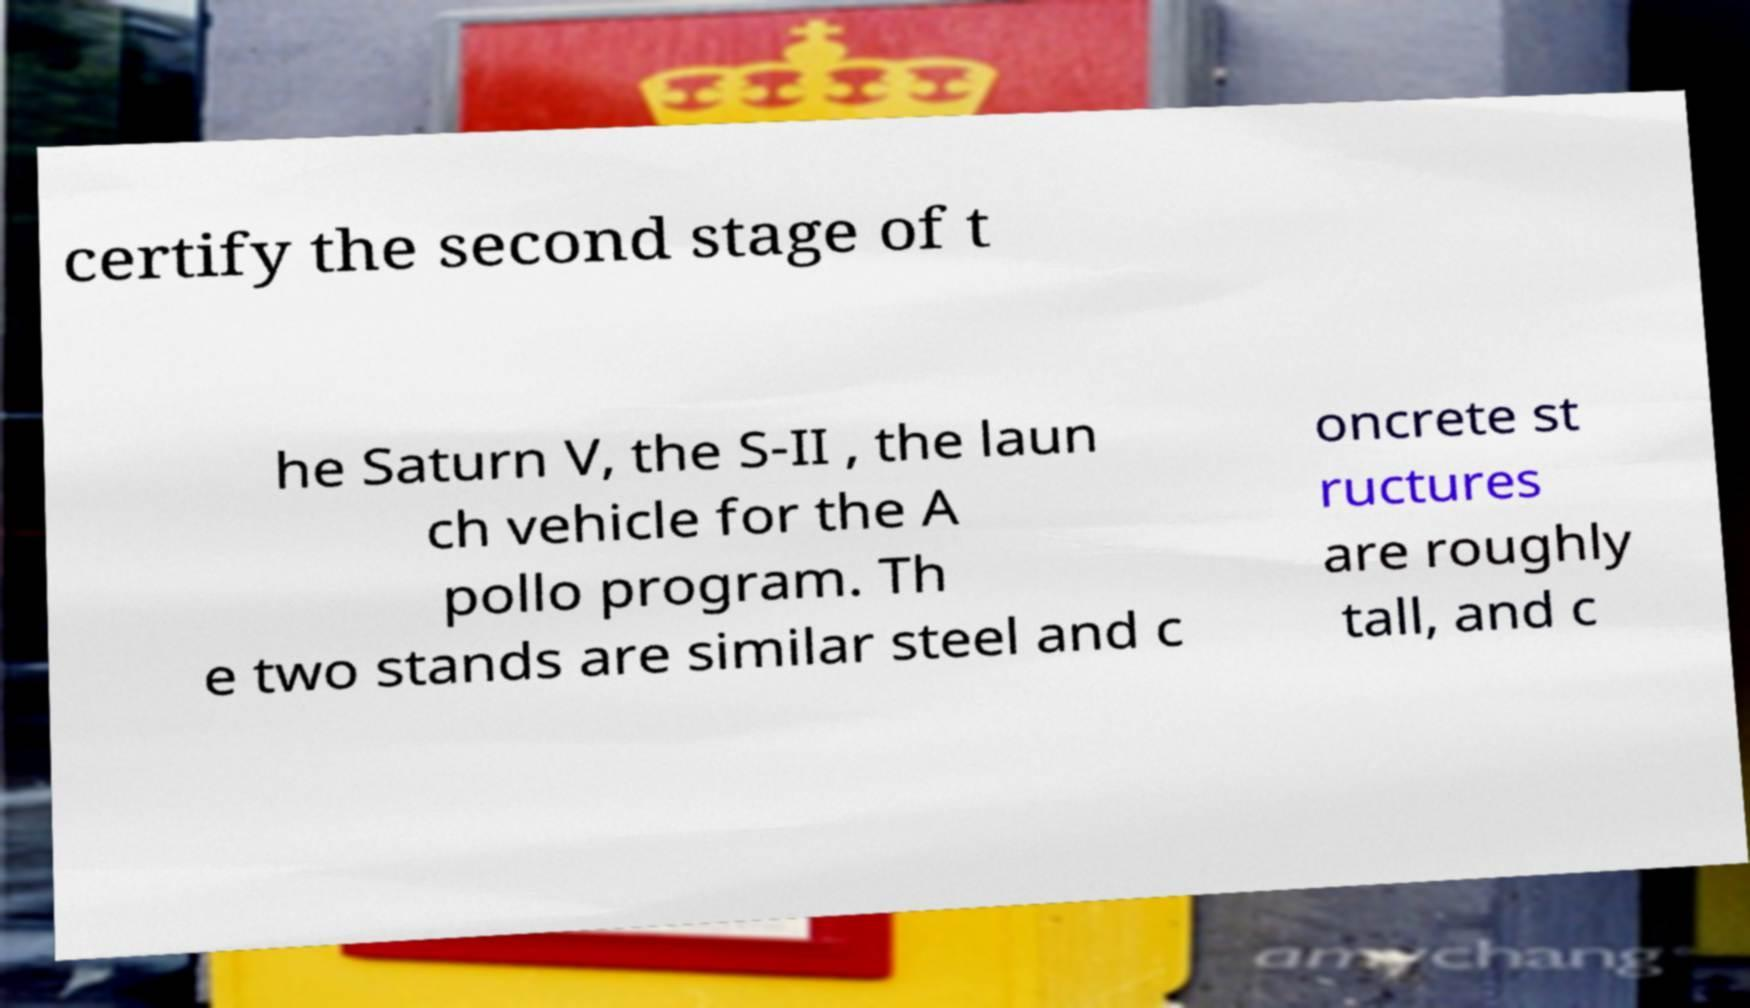There's text embedded in this image that I need extracted. Can you transcribe it verbatim? certify the second stage of t he Saturn V, the S-II , the laun ch vehicle for the A pollo program. Th e two stands are similar steel and c oncrete st ructures are roughly tall, and c 